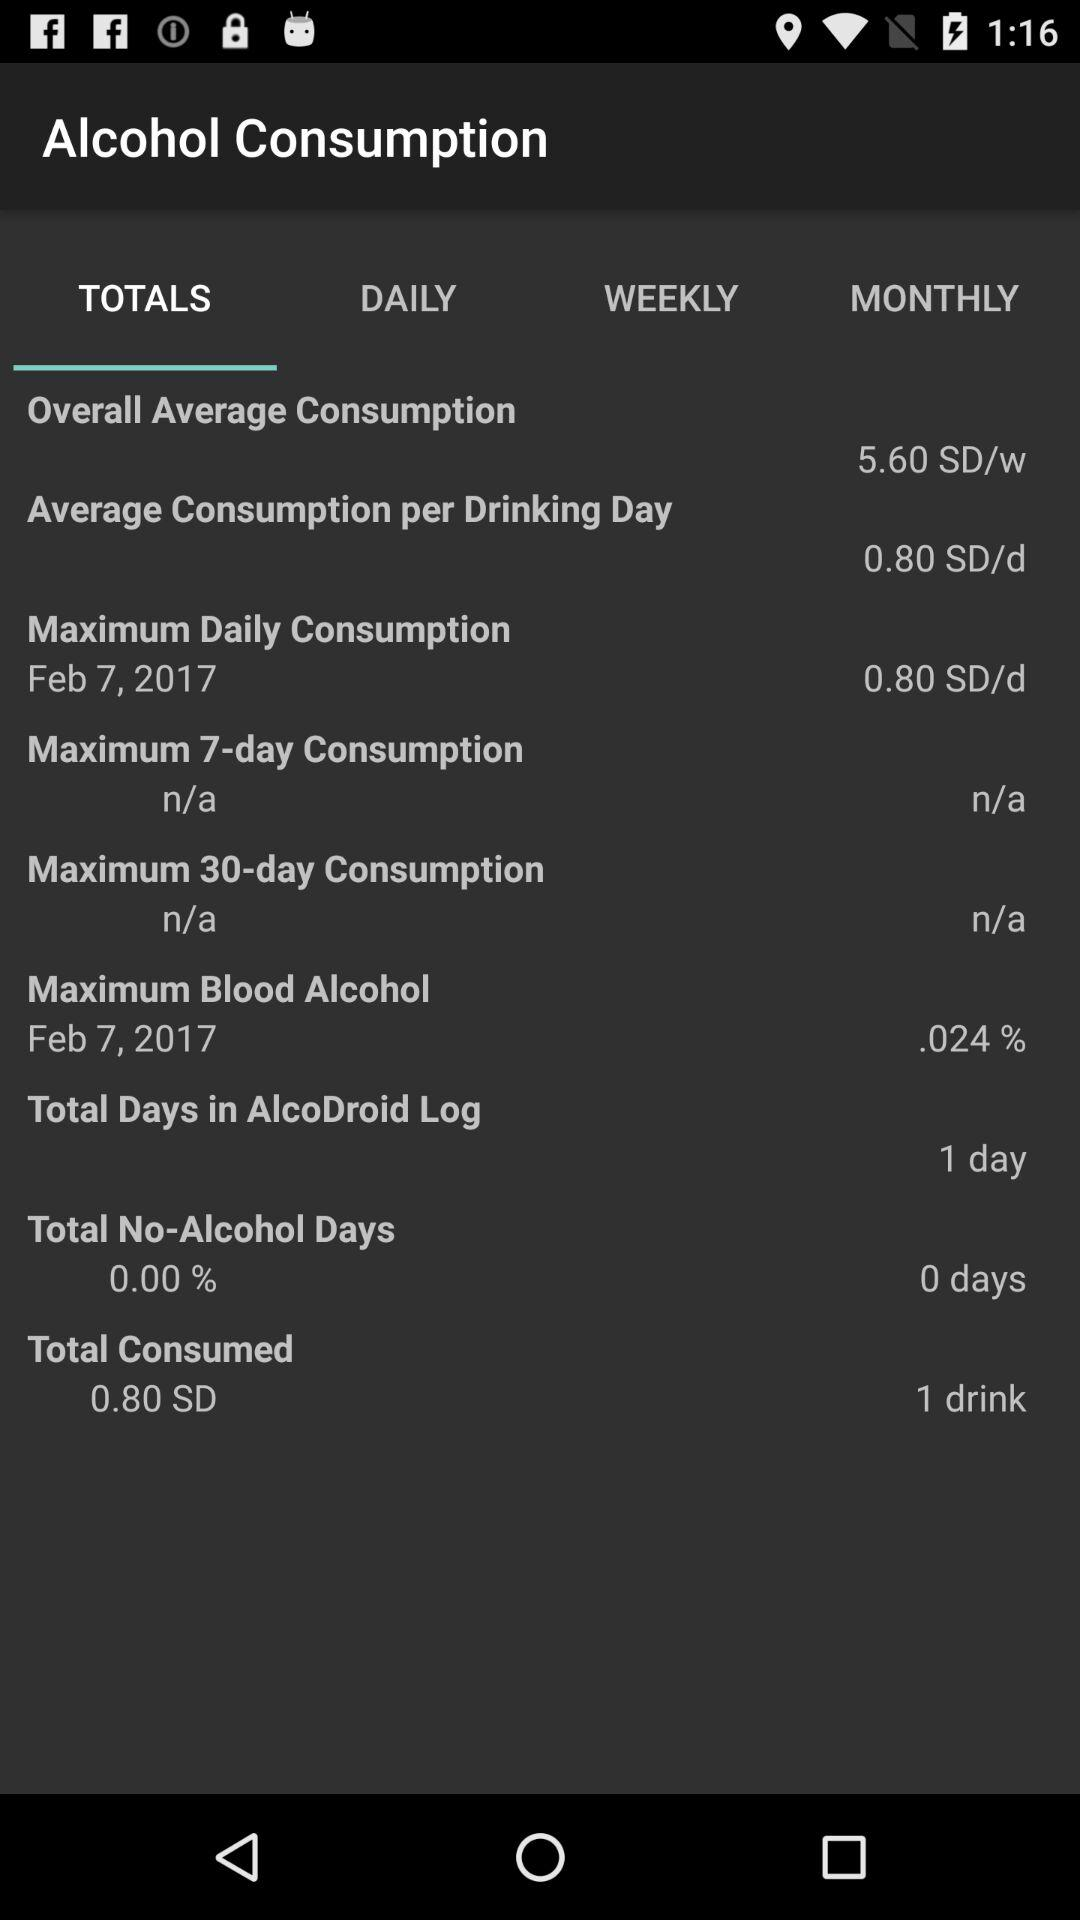What is the selected date for maximum daily consumption? The selected date is February 7, 2017. 